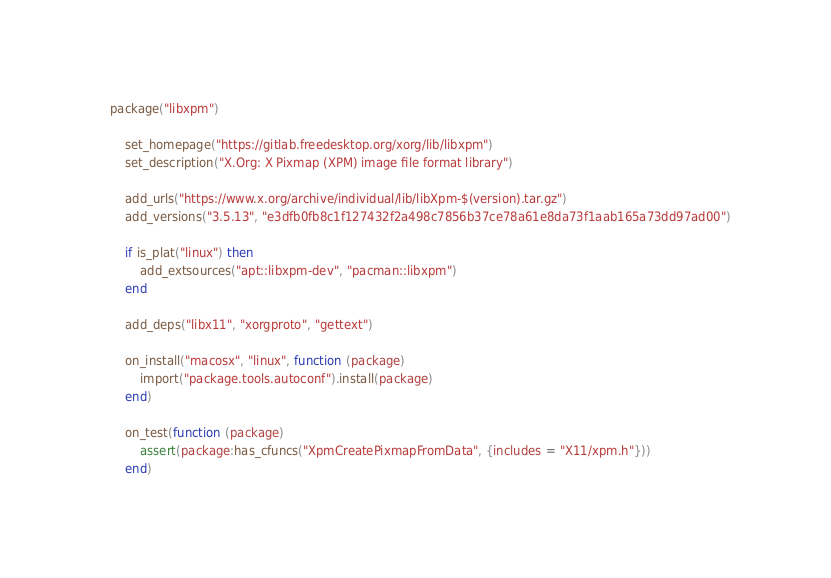<code> <loc_0><loc_0><loc_500><loc_500><_Lua_>package("libxpm")

    set_homepage("https://gitlab.freedesktop.org/xorg/lib/libxpm")
    set_description("X.Org: X Pixmap (XPM) image file format library")

    add_urls("https://www.x.org/archive/individual/lib/libXpm-$(version).tar.gz")
    add_versions("3.5.13", "e3dfb0fb8c1f127432f2a498c7856b37ce78a61e8da73f1aab165a73dd97ad00")

    if is_plat("linux") then
        add_extsources("apt::libxpm-dev", "pacman::libxpm")
    end

    add_deps("libx11", "xorgproto", "gettext")

    on_install("macosx", "linux", function (package)
        import("package.tools.autoconf").install(package)
    end)

    on_test(function (package)
        assert(package:has_cfuncs("XpmCreatePixmapFromData", {includes = "X11/xpm.h"}))
    end)
</code> 